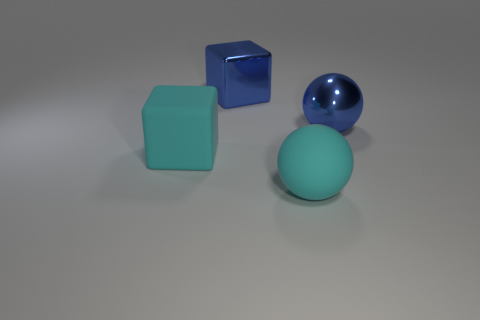Add 4 blue objects. How many blue objects exist? 6 Add 4 blocks. How many objects exist? 8 Subtract 0 brown cylinders. How many objects are left? 4 Subtract all red blocks. Subtract all cyan cylinders. How many blocks are left? 2 Subtract all red spheres. How many red blocks are left? 0 Subtract all big cyan matte cubes. Subtract all blue shiny blocks. How many objects are left? 2 Add 3 big metal cubes. How many big metal cubes are left? 4 